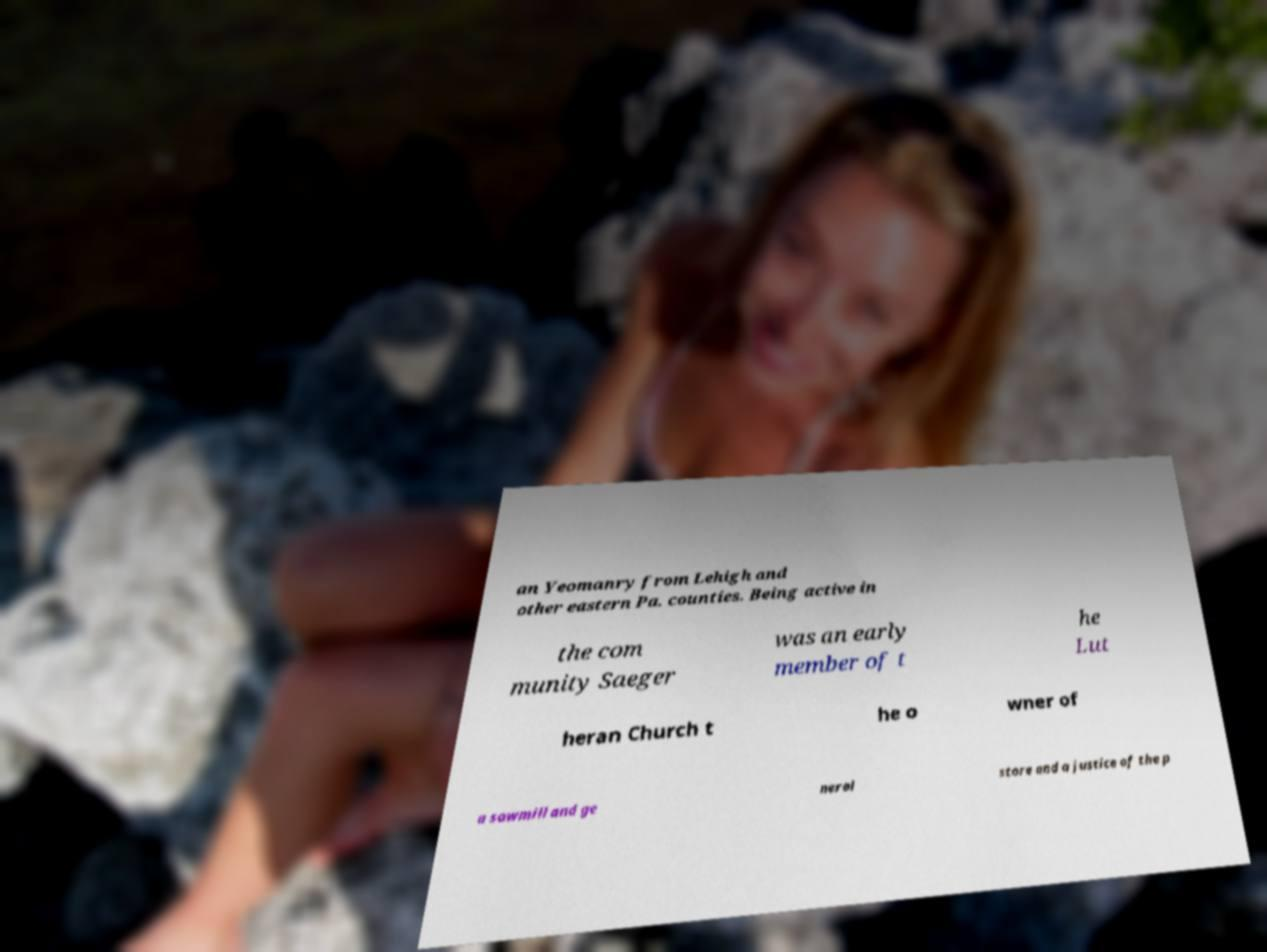For documentation purposes, I need the text within this image transcribed. Could you provide that? an Yeomanry from Lehigh and other eastern Pa. counties. Being active in the com munity Saeger was an early member of t he Lut heran Church t he o wner of a sawmill and ge neral store and a justice of the p 